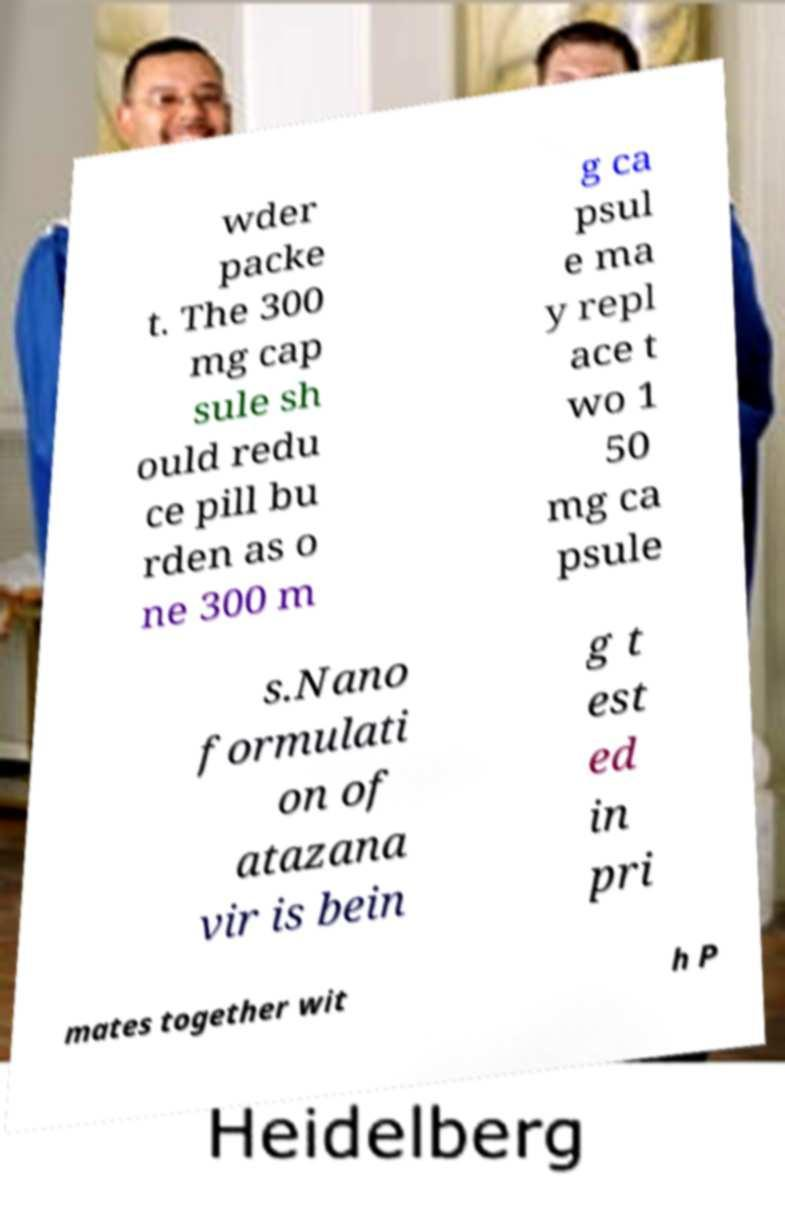For documentation purposes, I need the text within this image transcribed. Could you provide that? wder packe t. The 300 mg cap sule sh ould redu ce pill bu rden as o ne 300 m g ca psul e ma y repl ace t wo 1 50 mg ca psule s.Nano formulati on of atazana vir is bein g t est ed in pri mates together wit h P 